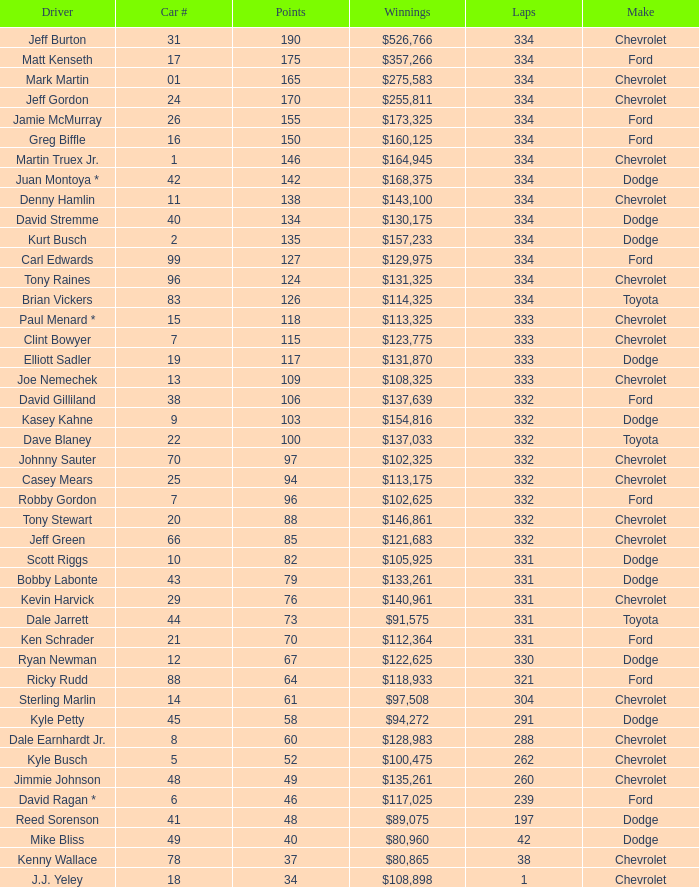Could you parse the entire table as a dict? {'header': ['Driver', 'Car #', 'Points', 'Winnings', 'Laps', 'Make'], 'rows': [['Jeff Burton', '31', '190', '$526,766', '334', 'Chevrolet'], ['Matt Kenseth', '17', '175', '$357,266', '334', 'Ford'], ['Mark Martin', '01', '165', '$275,583', '334', 'Chevrolet'], ['Jeff Gordon', '24', '170', '$255,811', '334', 'Chevrolet'], ['Jamie McMurray', '26', '155', '$173,325', '334', 'Ford'], ['Greg Biffle', '16', '150', '$160,125', '334', 'Ford'], ['Martin Truex Jr.', '1', '146', '$164,945', '334', 'Chevrolet'], ['Juan Montoya *', '42', '142', '$168,375', '334', 'Dodge'], ['Denny Hamlin', '11', '138', '$143,100', '334', 'Chevrolet'], ['David Stremme', '40', '134', '$130,175', '334', 'Dodge'], ['Kurt Busch', '2', '135', '$157,233', '334', 'Dodge'], ['Carl Edwards', '99', '127', '$129,975', '334', 'Ford'], ['Tony Raines', '96', '124', '$131,325', '334', 'Chevrolet'], ['Brian Vickers', '83', '126', '$114,325', '334', 'Toyota'], ['Paul Menard *', '15', '118', '$113,325', '333', 'Chevrolet'], ['Clint Bowyer', '7', '115', '$123,775', '333', 'Chevrolet'], ['Elliott Sadler', '19', '117', '$131,870', '333', 'Dodge'], ['Joe Nemechek', '13', '109', '$108,325', '333', 'Chevrolet'], ['David Gilliland', '38', '106', '$137,639', '332', 'Ford'], ['Kasey Kahne', '9', '103', '$154,816', '332', 'Dodge'], ['Dave Blaney', '22', '100', '$137,033', '332', 'Toyota'], ['Johnny Sauter', '70', '97', '$102,325', '332', 'Chevrolet'], ['Casey Mears', '25', '94', '$113,175', '332', 'Chevrolet'], ['Robby Gordon', '7', '96', '$102,625', '332', 'Ford'], ['Tony Stewart', '20', '88', '$146,861', '332', 'Chevrolet'], ['Jeff Green', '66', '85', '$121,683', '332', 'Chevrolet'], ['Scott Riggs', '10', '82', '$105,925', '331', 'Dodge'], ['Bobby Labonte', '43', '79', '$133,261', '331', 'Dodge'], ['Kevin Harvick', '29', '76', '$140,961', '331', 'Chevrolet'], ['Dale Jarrett', '44', '73', '$91,575', '331', 'Toyota'], ['Ken Schrader', '21', '70', '$112,364', '331', 'Ford'], ['Ryan Newman', '12', '67', '$122,625', '330', 'Dodge'], ['Ricky Rudd', '88', '64', '$118,933', '321', 'Ford'], ['Sterling Marlin', '14', '61', '$97,508', '304', 'Chevrolet'], ['Kyle Petty', '45', '58', '$94,272', '291', 'Dodge'], ['Dale Earnhardt Jr.', '8', '60', '$128,983', '288', 'Chevrolet'], ['Kyle Busch', '5', '52', '$100,475', '262', 'Chevrolet'], ['Jimmie Johnson', '48', '49', '$135,261', '260', 'Chevrolet'], ['David Ragan *', '6', '46', '$117,025', '239', 'Ford'], ['Reed Sorenson', '41', '48', '$89,075', '197', 'Dodge'], ['Mike Bliss', '49', '40', '$80,960', '42', 'Dodge'], ['Kenny Wallace', '78', '37', '$80,865', '38', 'Chevrolet'], ['J.J. Yeley', '18', '34', '$108,898', '1', 'Chevrolet']]} How many total laps did the Chevrolet that won $97,508 make? 1.0. 